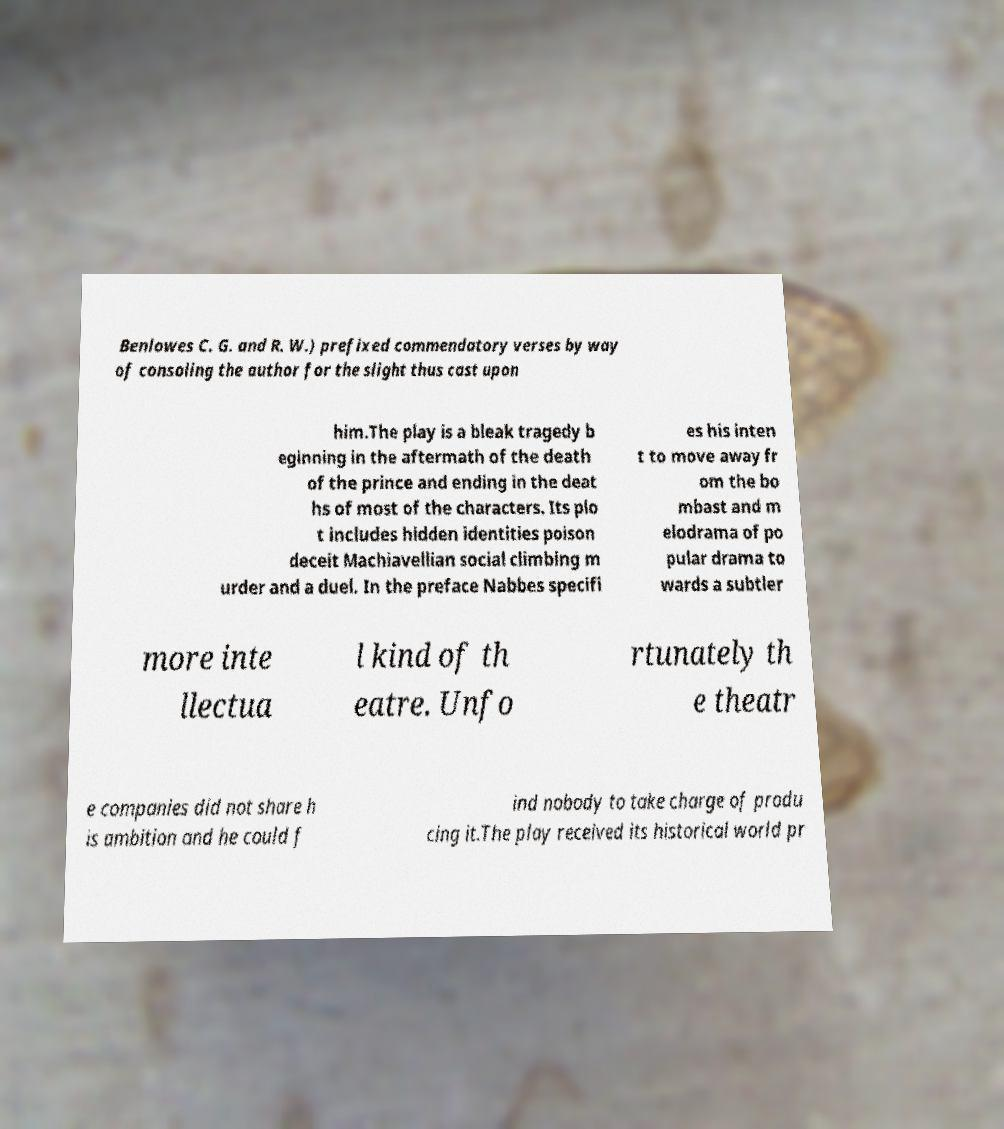There's text embedded in this image that I need extracted. Can you transcribe it verbatim? Benlowes C. G. and R. W.) prefixed commendatory verses by way of consoling the author for the slight thus cast upon him.The play is a bleak tragedy b eginning in the aftermath of the death of the prince and ending in the deat hs of most of the characters. Its plo t includes hidden identities poison deceit Machiavellian social climbing m urder and a duel. In the preface Nabbes specifi es his inten t to move away fr om the bo mbast and m elodrama of po pular drama to wards a subtler more inte llectua l kind of th eatre. Unfo rtunately th e theatr e companies did not share h is ambition and he could f ind nobody to take charge of produ cing it.The play received its historical world pr 